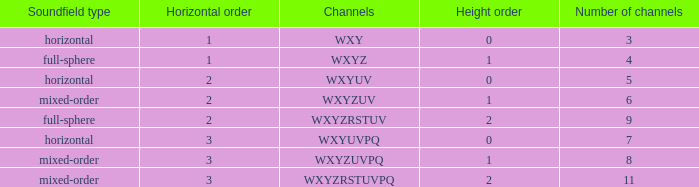If the channels is wxyzuv, what is the number of channels? 6.0. 